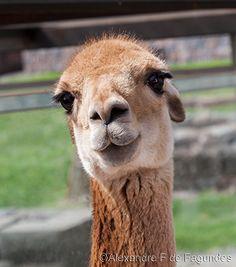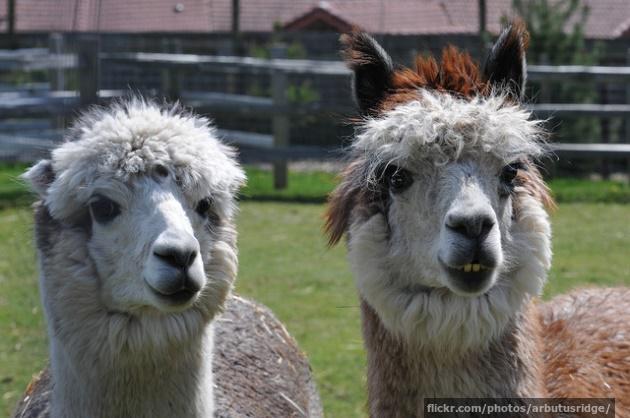The first image is the image on the left, the second image is the image on the right. Assess this claim about the two images: "In one of the images there is a brown llama standing behind a paler llama.". Correct or not? Answer yes or no. No. 